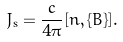<formula> <loc_0><loc_0><loc_500><loc_500>J _ { \mathrm s } = \frac { c } { 4 \pi } [ n , \{ B \} ] .</formula> 